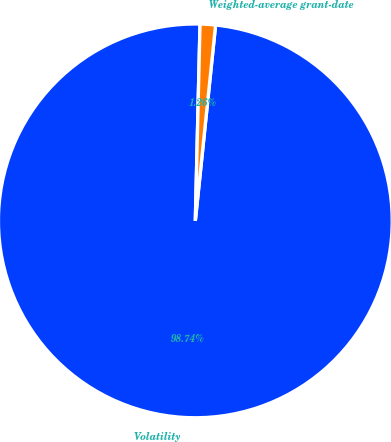<chart> <loc_0><loc_0><loc_500><loc_500><pie_chart><fcel>Volatility<fcel>Weighted-average grant-date<nl><fcel>98.74%<fcel>1.26%<nl></chart> 